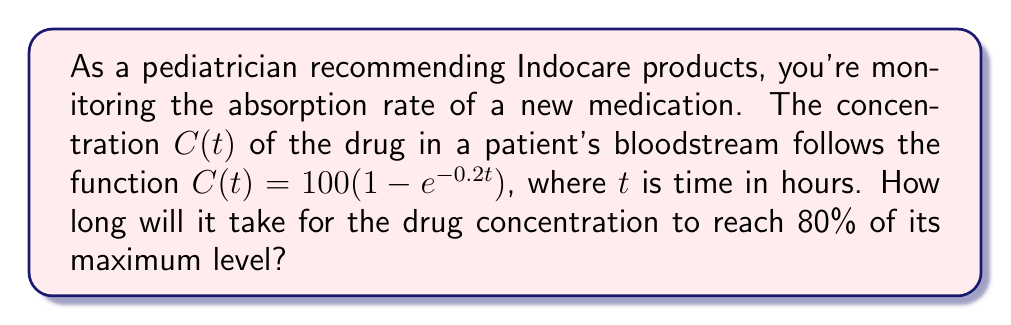What is the answer to this math problem? Let's approach this step-by-step:

1) The maximum concentration of the drug is the limit of $C(t)$ as $t$ approaches infinity:
   $\lim_{t \to \infty} C(t) = 100(1 - e^{-0.2t}) = 100$ mg/L

2) We want to find when the concentration reaches 80% of this maximum:
   $0.8 \times 100 = 80$ mg/L

3) Now, we set up the equation:
   $80 = 100(1 - e^{-0.2t})$

4) Divide both sides by 100:
   $0.8 = 1 - e^{-0.2t}$

5) Subtract both sides from 1:
   $0.2 = e^{-0.2t}$

6) Take the natural log of both sides:
   $\ln(0.2) = -0.2t$

7) Solve for $t$:
   $t = \frac{-\ln(0.2)}{0.2} = \frac{\ln(5)}{0.2} \approx 8.047$ hours
Answer: $\frac{\ln(5)}{0.2} \approx 8.047$ hours 